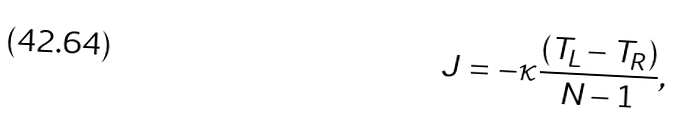Convert formula to latex. <formula><loc_0><loc_0><loc_500><loc_500>J = - \kappa \frac { ( T _ { L } - T _ { R } ) } { N - 1 } ,</formula> 